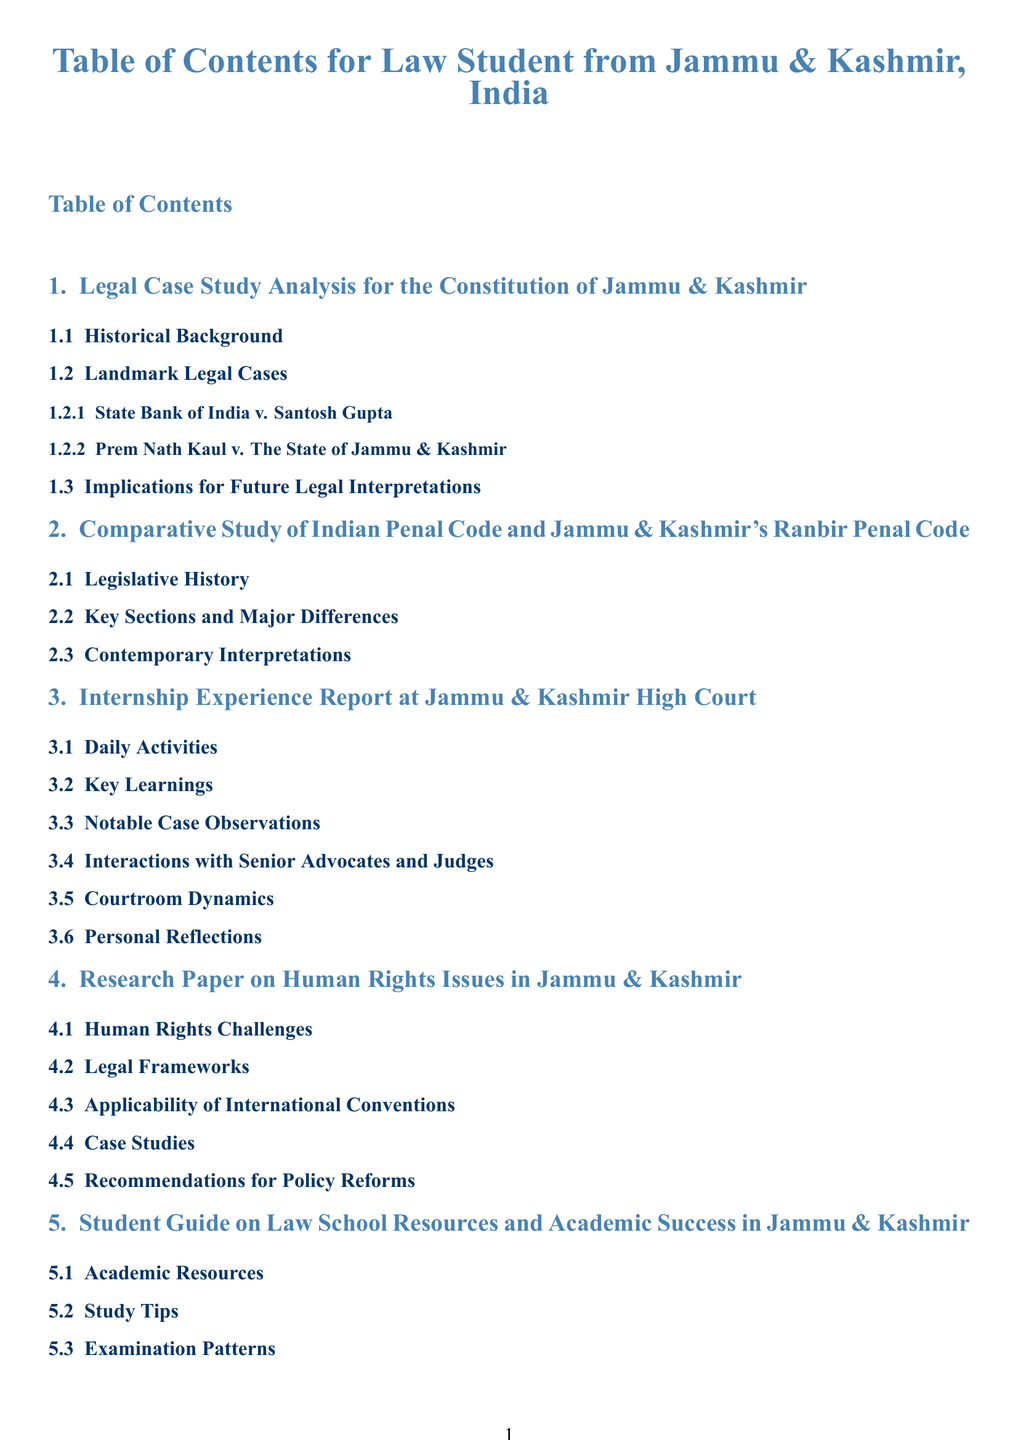What is the title of the first section? The title of the first section is mentioned in the Table of Contents as the first entry.
Answer: Legal Case Study Analysis for the Constitution of Jammu & Kashmir How many landmark legal cases are listed? The number of landmark legal cases is provided under the first section, indicating the specific number of cases discussed.
Answer: 2 What is the main focus of the second section? The main focus of the second section is the comparison between two specific legal codes, as indicated in the title.
Answer: Comparative Study of Indian Penal Code and Jammu & Kashmir's Ranbir Penal Code What section details personal reflections? Personal reflections are specifically located in the section that discusses internship experiences, particularly in one of its subsections.
Answer: Internship Experience Report at Jammu & Kashmir High Court Which section includes recommendations for policy reforms? This topic is explicitly mentioned in one of the subsections of the Human Rights issues section of the report.
Answer: Research Paper on Human Rights Issues in Jammu & Kashmir What topic does the fifth section cover? The fifth section is unique as it provides guidance tailored for law students, as described in its title.
Answer: Student Guide on Law School Resources and Academic Success in Jammu & Kashmir 